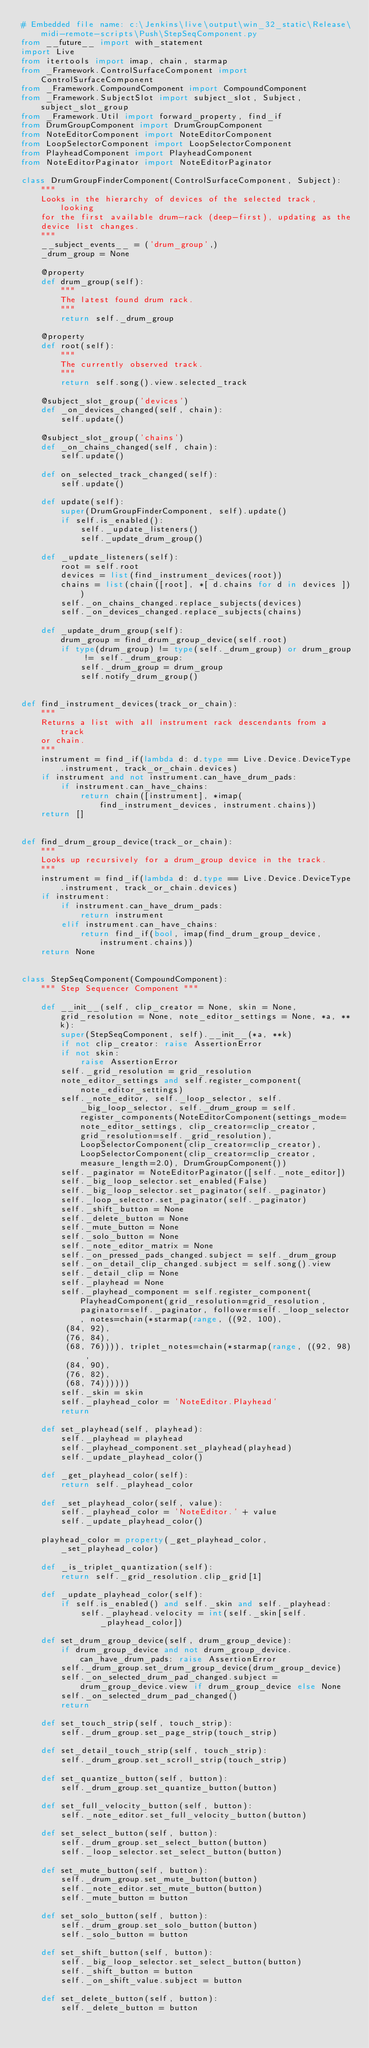Convert code to text. <code><loc_0><loc_0><loc_500><loc_500><_Python_># Embedded file name: c:\Jenkins\live\output\win_32_static\Release\midi-remote-scripts\Push\StepSeqComponent.py
from __future__ import with_statement
import Live
from itertools import imap, chain, starmap
from _Framework.ControlSurfaceComponent import ControlSurfaceComponent
from _Framework.CompoundComponent import CompoundComponent
from _Framework.SubjectSlot import subject_slot, Subject, subject_slot_group
from _Framework.Util import forward_property, find_if
from DrumGroupComponent import DrumGroupComponent
from NoteEditorComponent import NoteEditorComponent
from LoopSelectorComponent import LoopSelectorComponent
from PlayheadComponent import PlayheadComponent
from NoteEditorPaginator import NoteEditorPaginator

class DrumGroupFinderComponent(ControlSurfaceComponent, Subject):
    """
    Looks in the hierarchy of devices of the selected track, looking
    for the first available drum-rack (deep-first), updating as the
    device list changes.
    """
    __subject_events__ = ('drum_group',)
    _drum_group = None

    @property
    def drum_group(self):
        """
        The latest found drum rack.
        """
        return self._drum_group

    @property
    def root(self):
        """
        The currently observed track.
        """
        return self.song().view.selected_track

    @subject_slot_group('devices')
    def _on_devices_changed(self, chain):
        self.update()

    @subject_slot_group('chains')
    def _on_chains_changed(self, chain):
        self.update()

    def on_selected_track_changed(self):
        self.update()

    def update(self):
        super(DrumGroupFinderComponent, self).update()
        if self.is_enabled():
            self._update_listeners()
            self._update_drum_group()

    def _update_listeners(self):
        root = self.root
        devices = list(find_instrument_devices(root))
        chains = list(chain([root], *[ d.chains for d in devices ]))
        self._on_chains_changed.replace_subjects(devices)
        self._on_devices_changed.replace_subjects(chains)

    def _update_drum_group(self):
        drum_group = find_drum_group_device(self.root)
        if type(drum_group) != type(self._drum_group) or drum_group != self._drum_group:
            self._drum_group = drum_group
            self.notify_drum_group()


def find_instrument_devices(track_or_chain):
    """
    Returns a list with all instrument rack descendants from a track
    or chain.
    """
    instrument = find_if(lambda d: d.type == Live.Device.DeviceType.instrument, track_or_chain.devices)
    if instrument and not instrument.can_have_drum_pads:
        if instrument.can_have_chains:
            return chain([instrument], *imap(find_instrument_devices, instrument.chains))
    return []


def find_drum_group_device(track_or_chain):
    """
    Looks up recursively for a drum_group device in the track.
    """
    instrument = find_if(lambda d: d.type == Live.Device.DeviceType.instrument, track_or_chain.devices)
    if instrument:
        if instrument.can_have_drum_pads:
            return instrument
        elif instrument.can_have_chains:
            return find_if(bool, imap(find_drum_group_device, instrument.chains))
    return None


class StepSeqComponent(CompoundComponent):
    """ Step Sequencer Component """

    def __init__(self, clip_creator = None, skin = None, grid_resolution = None, note_editor_settings = None, *a, **k):
        super(StepSeqComponent, self).__init__(*a, **k)
        if not clip_creator: raise AssertionError
        if not skin:
            raise AssertionError
        self._grid_resolution = grid_resolution
        note_editor_settings and self.register_component(note_editor_settings)
        self._note_editor, self._loop_selector, self._big_loop_selector, self._drum_group = self.register_components(NoteEditorComponent(settings_mode=note_editor_settings, clip_creator=clip_creator, grid_resolution=self._grid_resolution), LoopSelectorComponent(clip_creator=clip_creator), LoopSelectorComponent(clip_creator=clip_creator, measure_length=2.0), DrumGroupComponent())
        self._paginator = NoteEditorPaginator([self._note_editor])
        self._big_loop_selector.set_enabled(False)
        self._big_loop_selector.set_paginator(self._paginator)
        self._loop_selector.set_paginator(self._paginator)
        self._shift_button = None
        self._delete_button = None
        self._mute_button = None
        self._solo_button = None
        self._note_editor_matrix = None
        self._on_pressed_pads_changed.subject = self._drum_group
        self._on_detail_clip_changed.subject = self.song().view
        self._detail_clip = None
        self._playhead = None
        self._playhead_component = self.register_component(PlayheadComponent(grid_resolution=grid_resolution, paginator=self._paginator, follower=self._loop_selector, notes=chain(*starmap(range, ((92, 100),
         (84, 92),
         (76, 84),
         (68, 76)))), triplet_notes=chain(*starmap(range, ((92, 98),
         (84, 90),
         (76, 82),
         (68, 74))))))
        self._skin = skin
        self._playhead_color = 'NoteEditor.Playhead'
        return

    def set_playhead(self, playhead):
        self._playhead = playhead
        self._playhead_component.set_playhead(playhead)
        self._update_playhead_color()

    def _get_playhead_color(self):
        return self._playhead_color

    def _set_playhead_color(self, value):
        self._playhead_color = 'NoteEditor.' + value
        self._update_playhead_color()

    playhead_color = property(_get_playhead_color, _set_playhead_color)

    def _is_triplet_quantization(self):
        return self._grid_resolution.clip_grid[1]

    def _update_playhead_color(self):
        if self.is_enabled() and self._skin and self._playhead:
            self._playhead.velocity = int(self._skin[self._playhead_color])

    def set_drum_group_device(self, drum_group_device):
        if drum_group_device and not drum_group_device.can_have_drum_pads: raise AssertionError
        self._drum_group.set_drum_group_device(drum_group_device)
        self._on_selected_drum_pad_changed.subject = drum_group_device.view if drum_group_device else None
        self._on_selected_drum_pad_changed()
        return

    def set_touch_strip(self, touch_strip):
        self._drum_group.set_page_strip(touch_strip)

    def set_detail_touch_strip(self, touch_strip):
        self._drum_group.set_scroll_strip(touch_strip)

    def set_quantize_button(self, button):
        self._drum_group.set_quantize_button(button)

    def set_full_velocity_button(self, button):
        self._note_editor.set_full_velocity_button(button)

    def set_select_button(self, button):
        self._drum_group.set_select_button(button)
        self._loop_selector.set_select_button(button)

    def set_mute_button(self, button):
        self._drum_group.set_mute_button(button)
        self._note_editor.set_mute_button(button)
        self._mute_button = button

    def set_solo_button(self, button):
        self._drum_group.set_solo_button(button)
        self._solo_button = button

    def set_shift_button(self, button):
        self._big_loop_selector.set_select_button(button)
        self._shift_button = button
        self._on_shift_value.subject = button

    def set_delete_button(self, button):
        self._delete_button = button</code> 